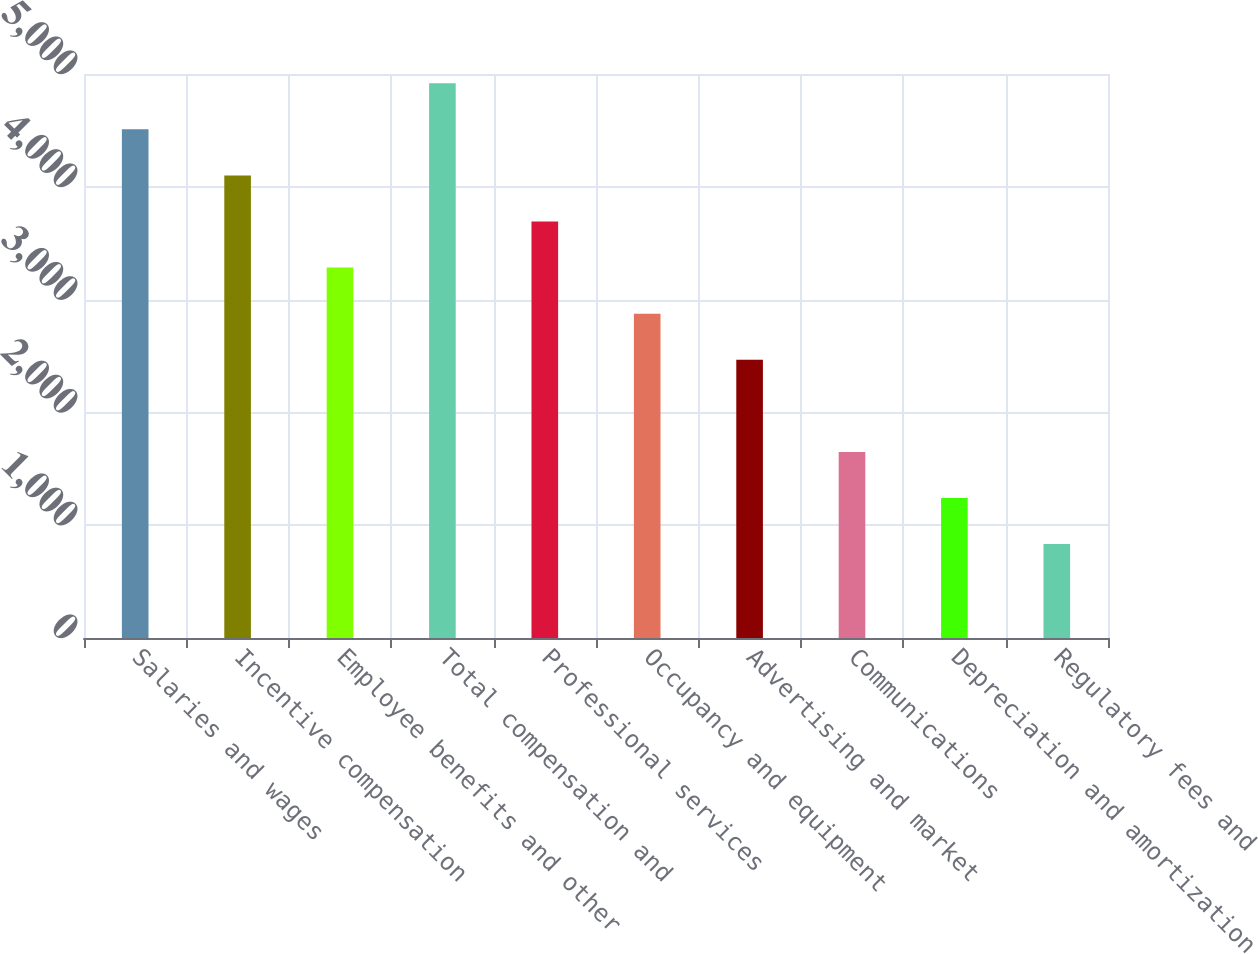Convert chart. <chart><loc_0><loc_0><loc_500><loc_500><bar_chart><fcel>Salaries and wages<fcel>Incentive compensation<fcel>Employee benefits and other<fcel>Total compensation and<fcel>Professional services<fcel>Occupancy and equipment<fcel>Advertising and market<fcel>Communications<fcel>Depreciation and amortization<fcel>Regulatory fees and<nl><fcel>4509.59<fcel>4101<fcel>3283.82<fcel>4918.18<fcel>3692.41<fcel>2875.23<fcel>2466.64<fcel>1649.46<fcel>1240.87<fcel>832.28<nl></chart> 